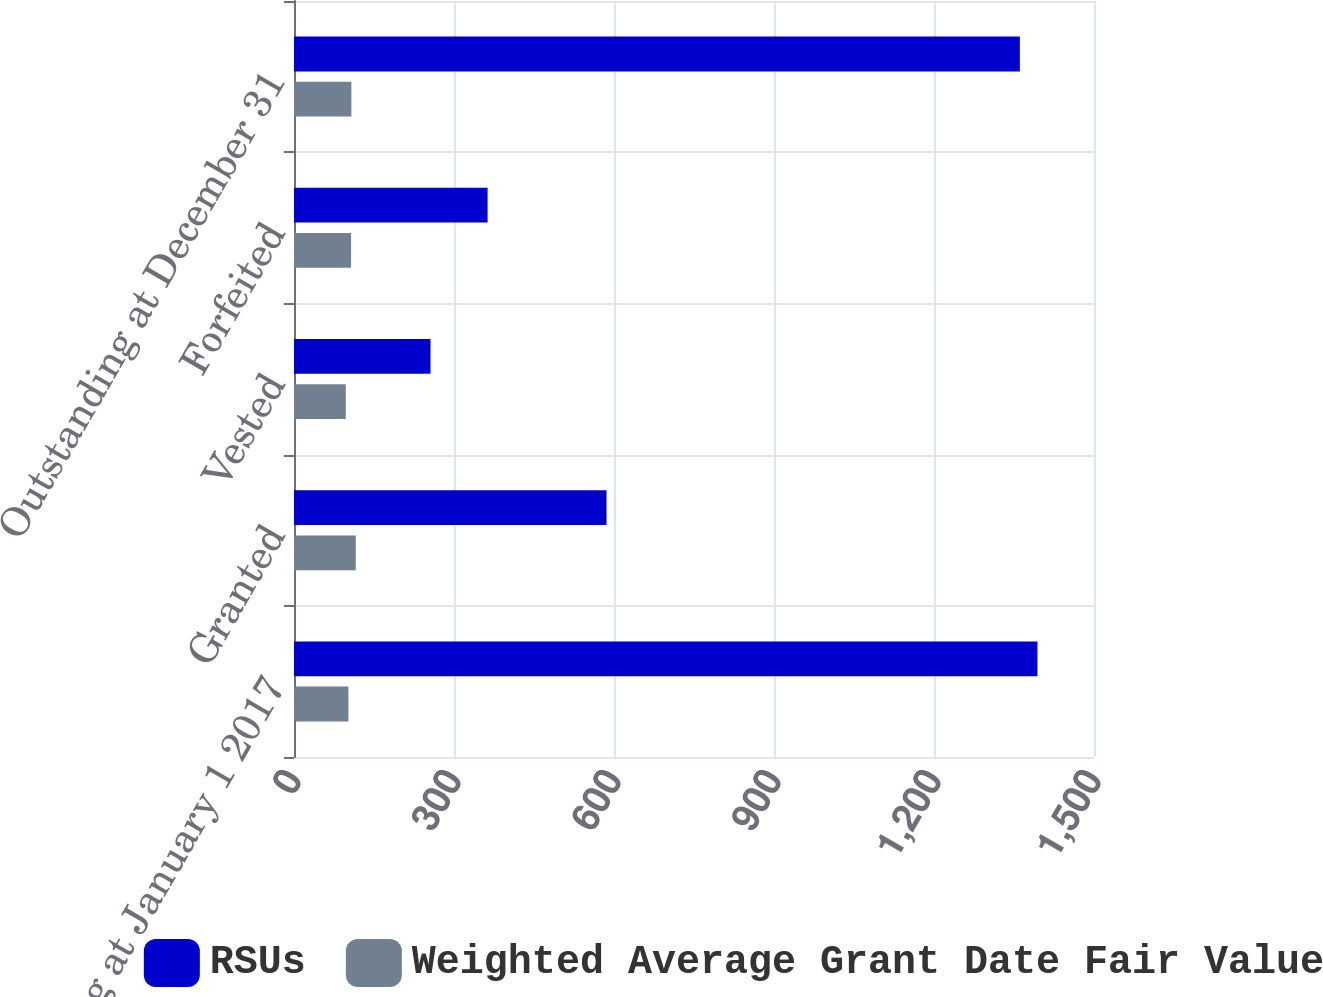<chart> <loc_0><loc_0><loc_500><loc_500><stacked_bar_chart><ecel><fcel>Outstanding at January 1 2017<fcel>Granted<fcel>Vested<fcel>Forfeited<fcel>Outstanding at December 31<nl><fcel>RSUs<fcel>1394<fcel>586<fcel>256<fcel>363<fcel>1361<nl><fcel>Weighted Average Grant Date Fair Value<fcel>102.04<fcel>115.77<fcel>97.12<fcel>107.02<fcel>107.56<nl></chart> 